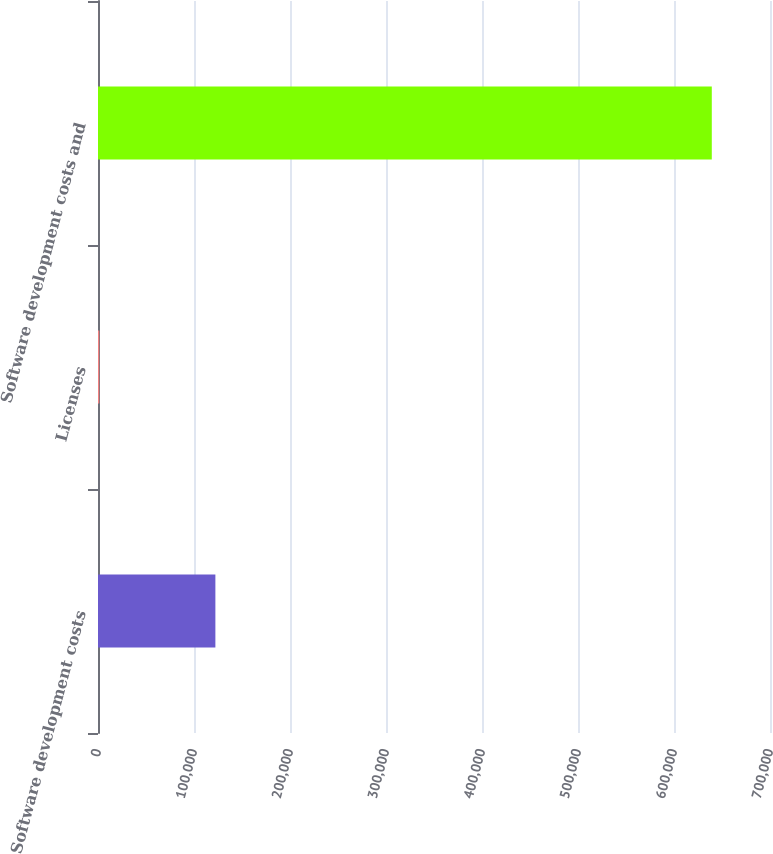<chart> <loc_0><loc_0><loc_500><loc_500><bar_chart><fcel>Software development costs<fcel>Licenses<fcel>Software development costs and<nl><fcel>122270<fcel>1338<fcel>639369<nl></chart> 